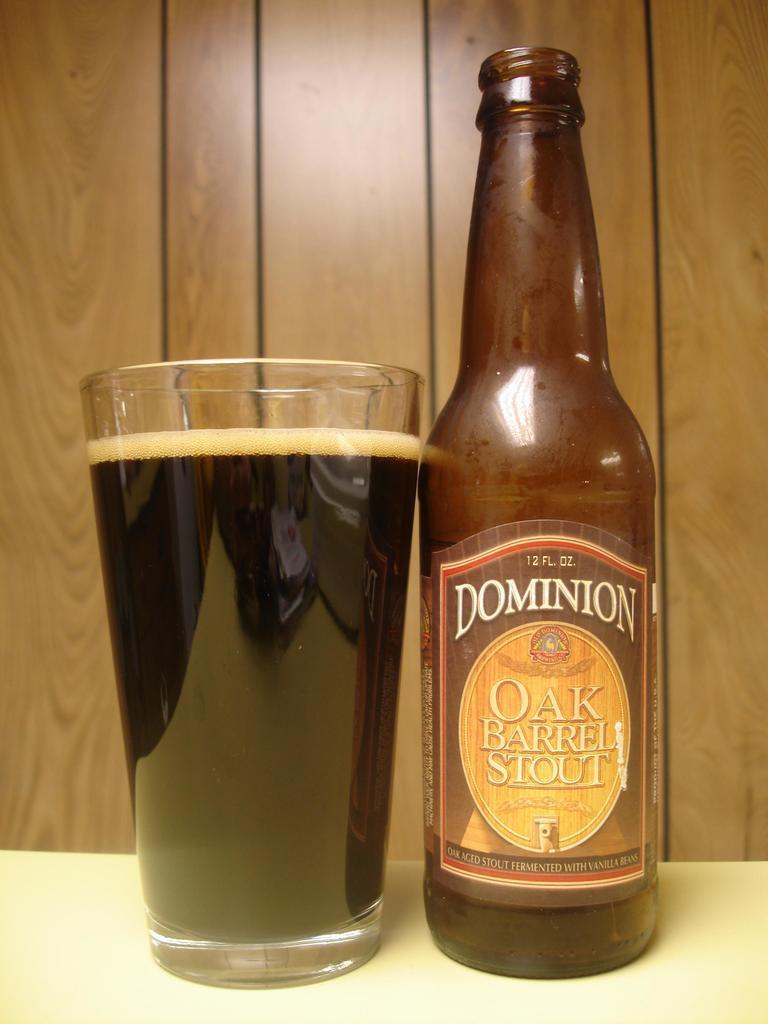Can you describe this image briefly? As we can see in the image there is a bottle and glass. 